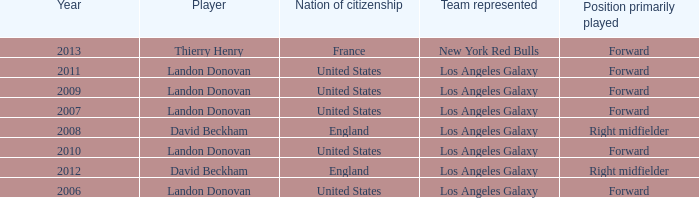Can you parse all the data within this table? {'header': ['Year', 'Player', 'Nation of citizenship', 'Team represented', 'Position primarily played'], 'rows': [['2013', 'Thierry Henry', 'France', 'New York Red Bulls', 'Forward'], ['2011', 'Landon Donovan', 'United States', 'Los Angeles Galaxy', 'Forward'], ['2009', 'Landon Donovan', 'United States', 'Los Angeles Galaxy', 'Forward'], ['2007', 'Landon Donovan', 'United States', 'Los Angeles Galaxy', 'Forward'], ['2008', 'David Beckham', 'England', 'Los Angeles Galaxy', 'Right midfielder'], ['2010', 'Landon Donovan', 'United States', 'Los Angeles Galaxy', 'Forward'], ['2012', 'David Beckham', 'England', 'Los Angeles Galaxy', 'Right midfielder'], ['2006', 'Landon Donovan', 'United States', 'Los Angeles Galaxy', 'Forward']]} What is the sum of all the years that Landon Donovan won the ESPY award? 5.0. 